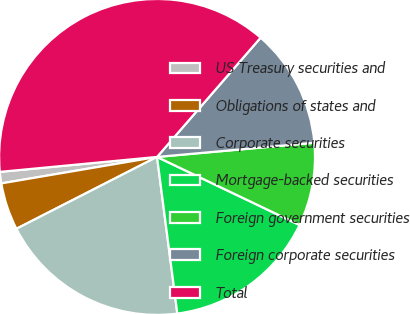Convert chart to OTSL. <chart><loc_0><loc_0><loc_500><loc_500><pie_chart><fcel>US Treasury securities and<fcel>Obligations of states and<fcel>Corporate securities<fcel>Mortgage-backed securities<fcel>Foreign government securities<fcel>Foreign corporate securities<fcel>Total<nl><fcel>1.17%<fcel>4.84%<fcel>19.53%<fcel>15.86%<fcel>8.52%<fcel>12.19%<fcel>37.89%<nl></chart> 